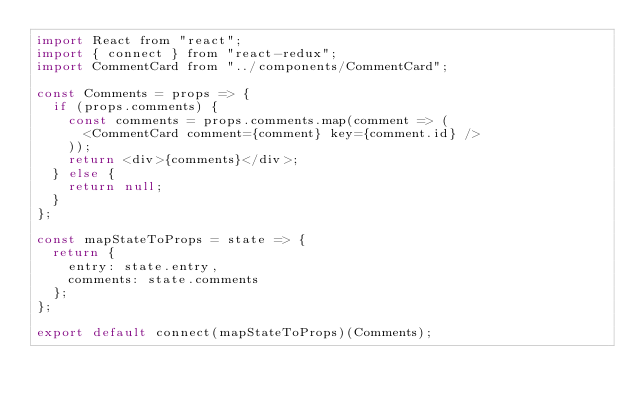Convert code to text. <code><loc_0><loc_0><loc_500><loc_500><_JavaScript_>import React from "react";
import { connect } from "react-redux";
import CommentCard from "../components/CommentCard";

const Comments = props => {
  if (props.comments) {
    const comments = props.comments.map(comment => (
      <CommentCard comment={comment} key={comment.id} />
    ));
    return <div>{comments}</div>;
  } else {
    return null;
  }
};

const mapStateToProps = state => {
  return {
    entry: state.entry,
    comments: state.comments
  };
};

export default connect(mapStateToProps)(Comments);
</code> 